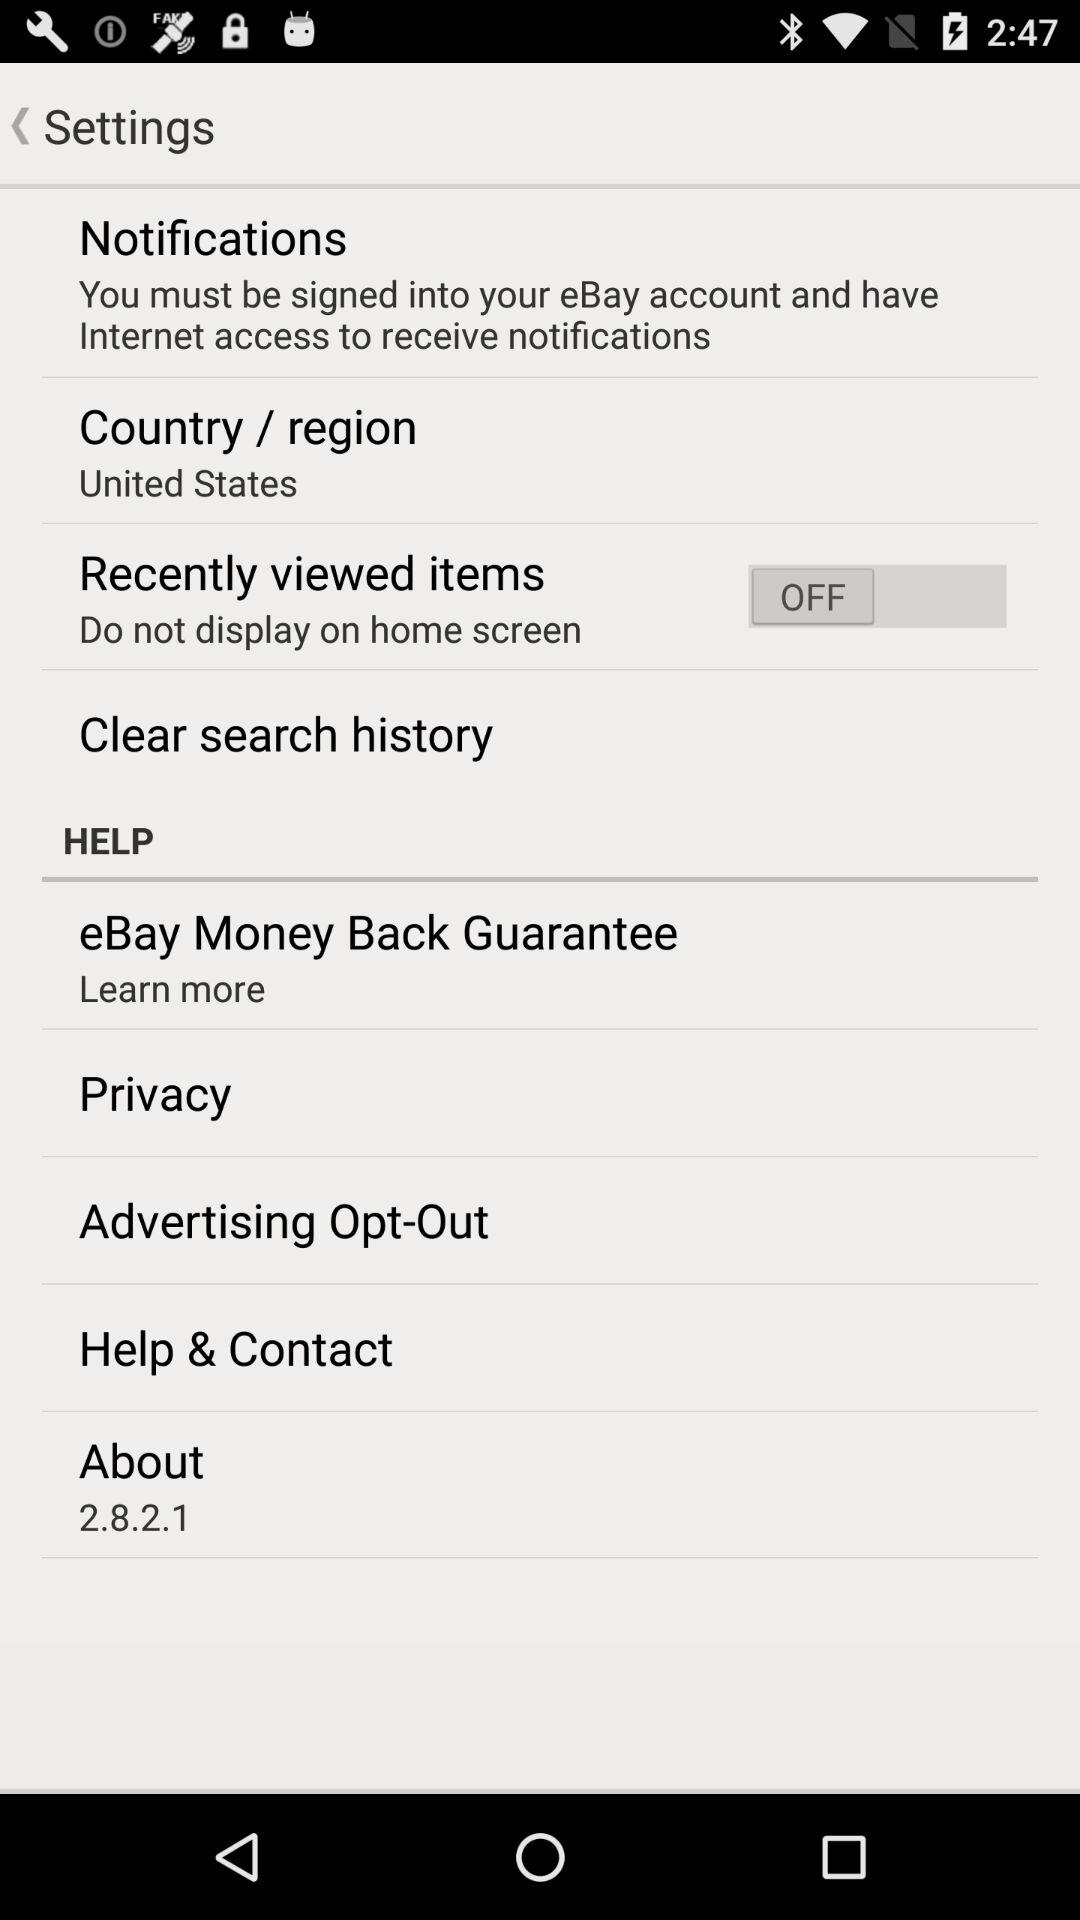What is the name of the country? The name of the country is the United States. 